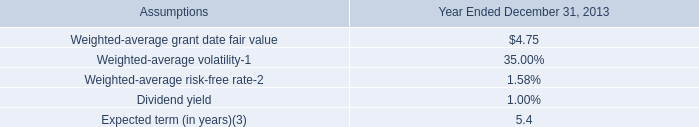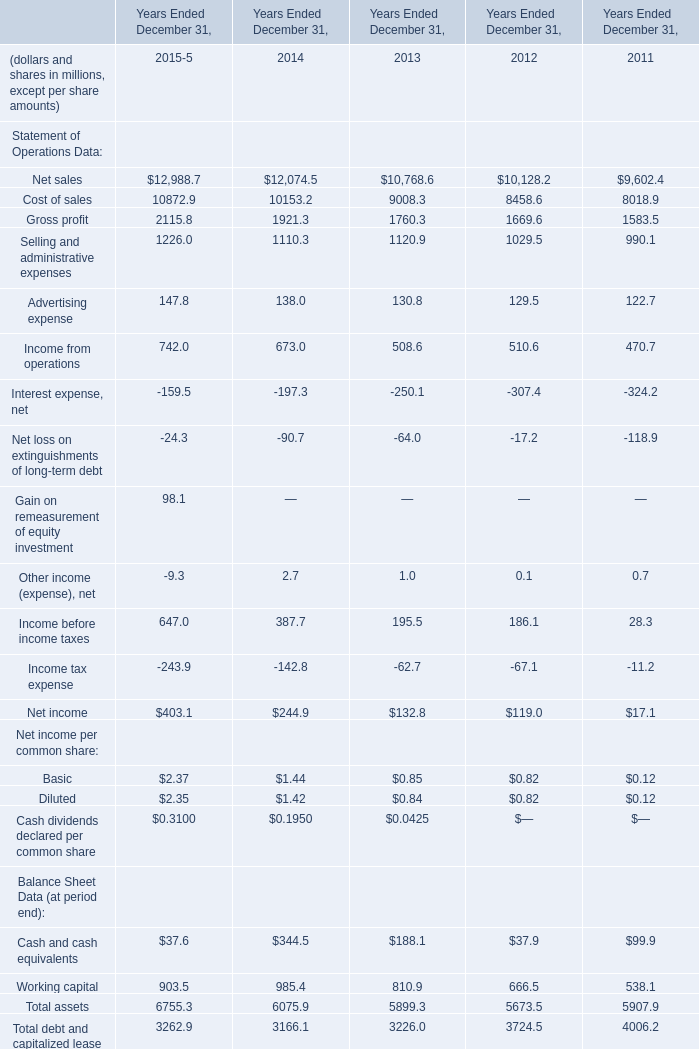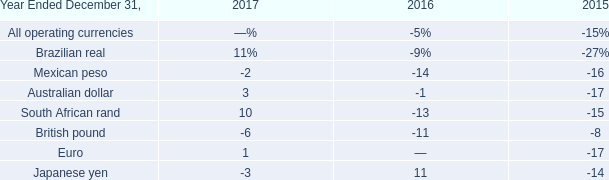as of dec 13 , 2013 , if all forfeited shares became vested , what percentage of shares would be vested? 
Computations: ((5931 + 1200544) / 3798508)
Answer: 0.31762. 